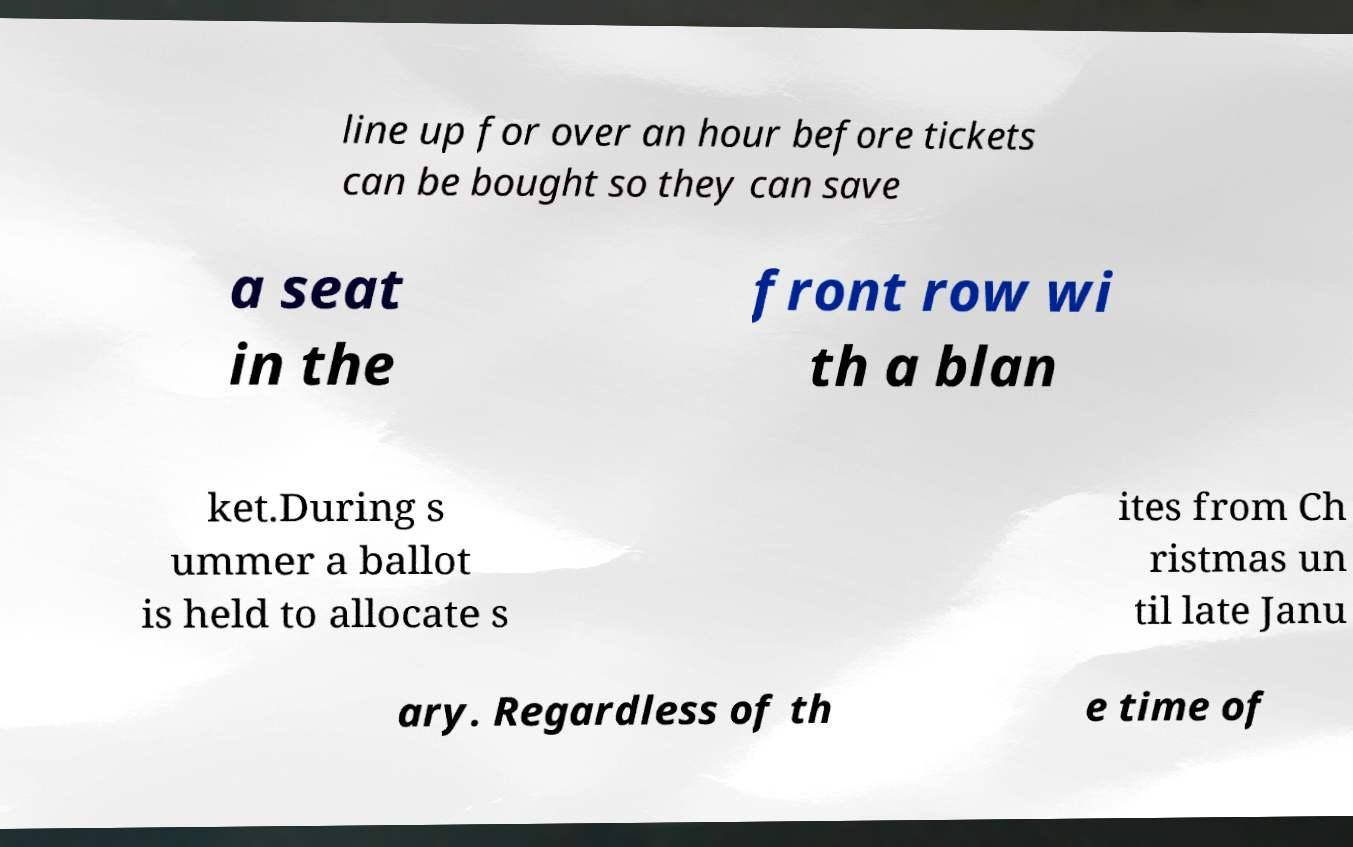What messages or text are displayed in this image? I need them in a readable, typed format. line up for over an hour before tickets can be bought so they can save a seat in the front row wi th a blan ket.During s ummer a ballot is held to allocate s ites from Ch ristmas un til late Janu ary. Regardless of th e time of 